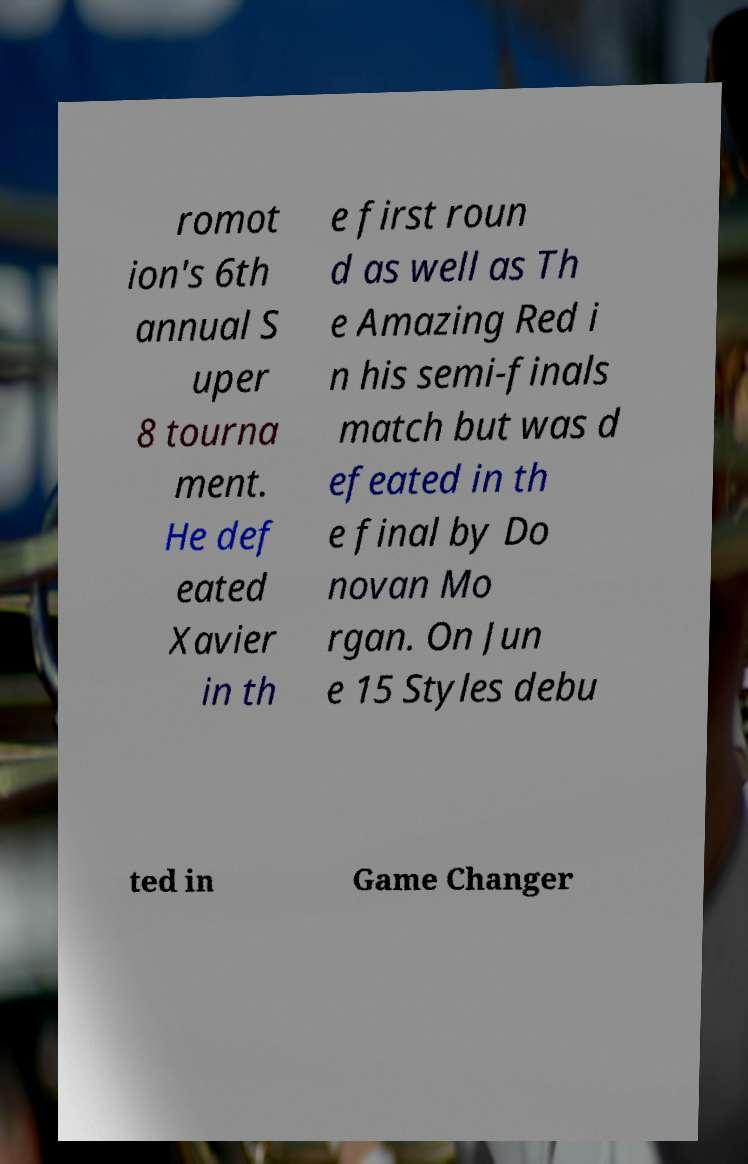Please identify and transcribe the text found in this image. romot ion's 6th annual S uper 8 tourna ment. He def eated Xavier in th e first roun d as well as Th e Amazing Red i n his semi-finals match but was d efeated in th e final by Do novan Mo rgan. On Jun e 15 Styles debu ted in Game Changer 